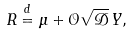<formula> <loc_0><loc_0><loc_500><loc_500>R \overset { d } { = } \mu + \mathcal { O } \sqrt { \mathcal { D } } \, Y ,</formula> 